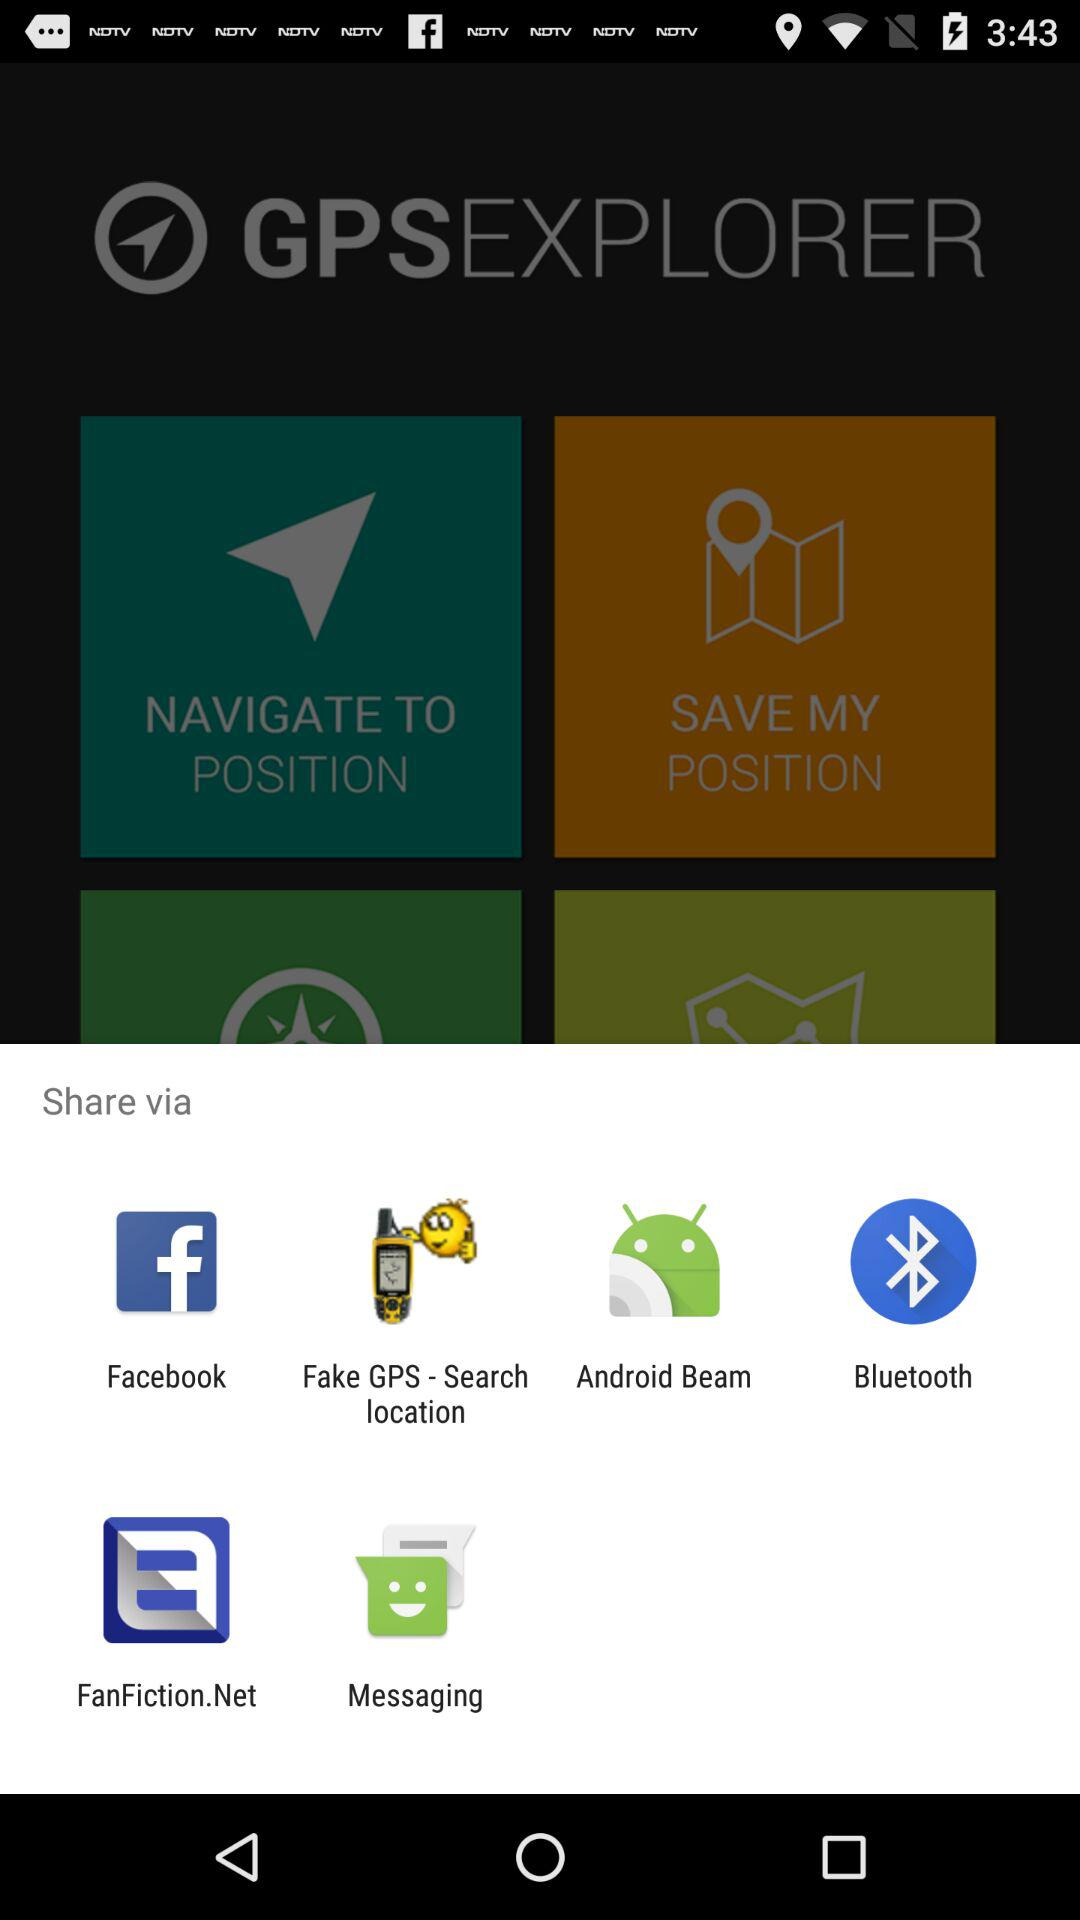Which application can I use to share? You can use "Facebook", "Fake GPS - Search location", "Android Beam", "Bluetooth", "FanFiction.Net" and "Messaging" applications to share. 